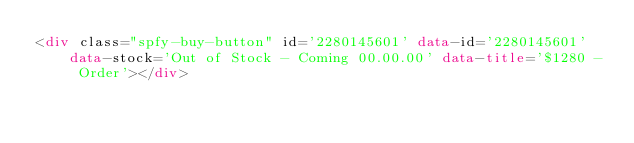<code> <loc_0><loc_0><loc_500><loc_500><_HTML_><div class="spfy-buy-button" id='2280145601' data-id='2280145601' data-stock='Out of Stock - Coming 00.00.00' data-title='$1280 - Order'></div></code> 